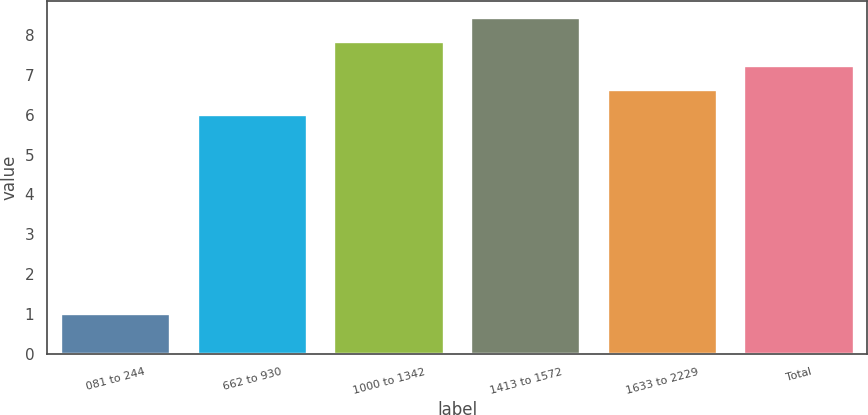Convert chart to OTSL. <chart><loc_0><loc_0><loc_500><loc_500><bar_chart><fcel>081 to 244<fcel>662 to 930<fcel>1000 to 1342<fcel>1413 to 1572<fcel>1633 to 2229<fcel>Total<nl><fcel>1<fcel>6<fcel>7.83<fcel>8.44<fcel>6.61<fcel>7.22<nl></chart> 